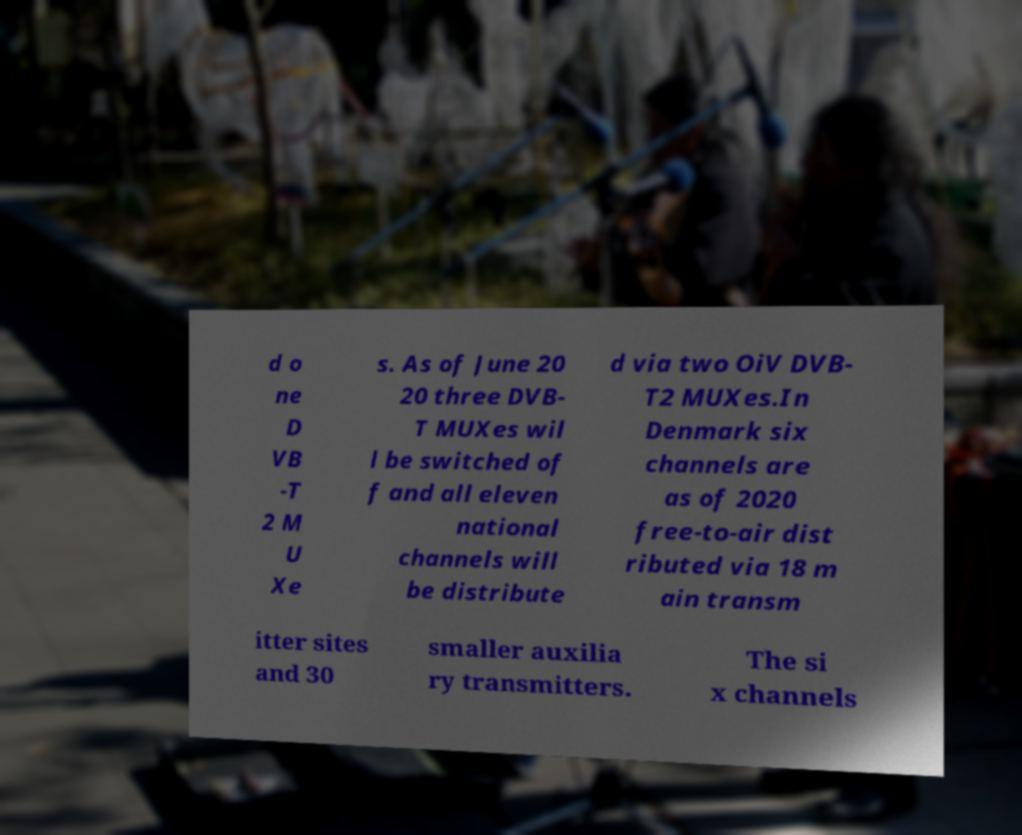What messages or text are displayed in this image? I need them in a readable, typed format. d o ne D VB -T 2 M U Xe s. As of June 20 20 three DVB- T MUXes wil l be switched of f and all eleven national channels will be distribute d via two OiV DVB- T2 MUXes.In Denmark six channels are as of 2020 free-to-air dist ributed via 18 m ain transm itter sites and 30 smaller auxilia ry transmitters. The si x channels 